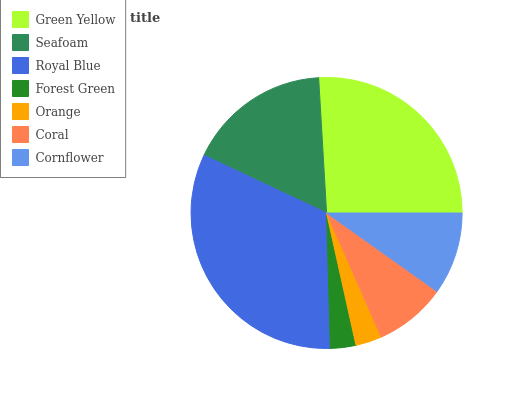Is Forest Green the minimum?
Answer yes or no. Yes. Is Royal Blue the maximum?
Answer yes or no. Yes. Is Seafoam the minimum?
Answer yes or no. No. Is Seafoam the maximum?
Answer yes or no. No. Is Green Yellow greater than Seafoam?
Answer yes or no. Yes. Is Seafoam less than Green Yellow?
Answer yes or no. Yes. Is Seafoam greater than Green Yellow?
Answer yes or no. No. Is Green Yellow less than Seafoam?
Answer yes or no. No. Is Cornflower the high median?
Answer yes or no. Yes. Is Cornflower the low median?
Answer yes or no. Yes. Is Green Yellow the high median?
Answer yes or no. No. Is Royal Blue the low median?
Answer yes or no. No. 